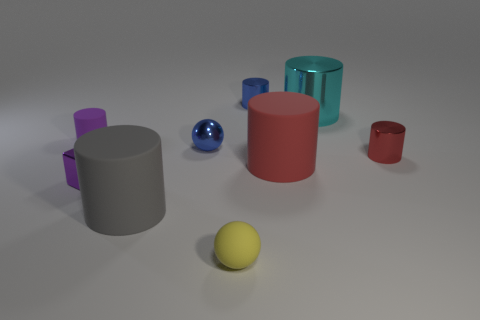Subtract 2 cylinders. How many cylinders are left? 4 Subtract all gray cylinders. How many cylinders are left? 5 Subtract all tiny rubber cylinders. How many cylinders are left? 5 Subtract all gray cylinders. Subtract all purple balls. How many cylinders are left? 5 Add 1 green spheres. How many objects exist? 10 Subtract all cylinders. How many objects are left? 3 Add 2 large rubber cylinders. How many large rubber cylinders are left? 4 Add 3 tiny red cylinders. How many tiny red cylinders exist? 4 Subtract 0 green cubes. How many objects are left? 9 Subtract all big yellow spheres. Subtract all small purple cubes. How many objects are left? 8 